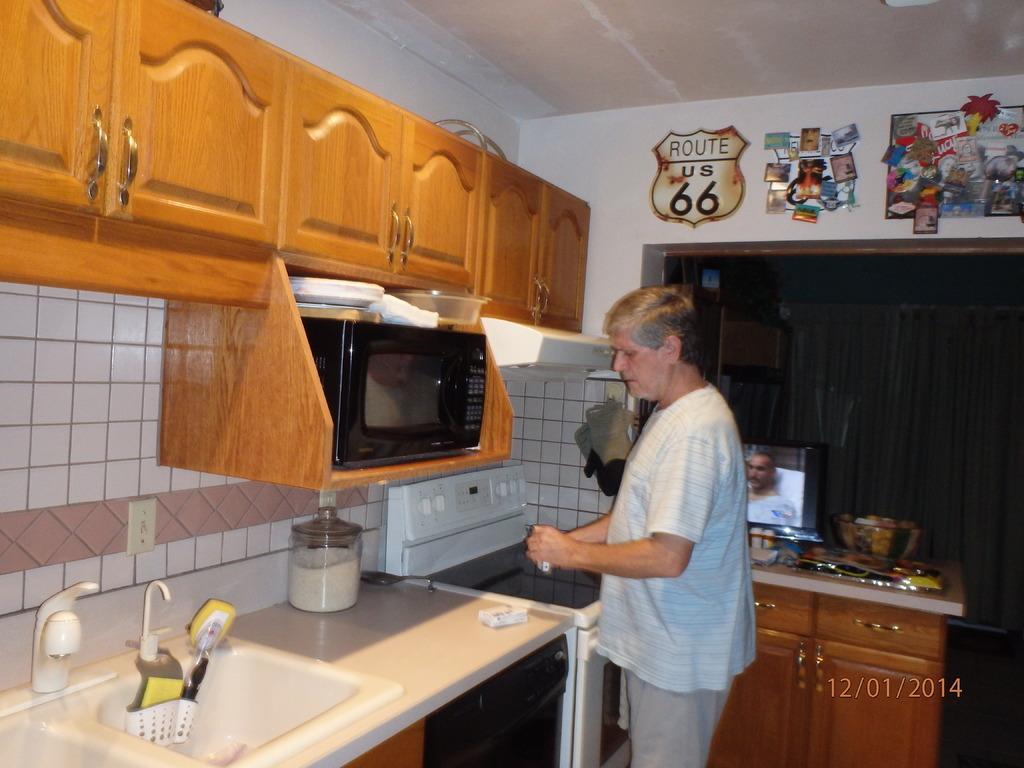Could you give a brief overview of what you see in this image? In this image I can see a kitchen, at the top there are cupboards and the wall there are some stickers attached to the wall, bottom of cupboard there is a micro oven visible ,at the bottom there is a kitchen cabinet,sink, glass jar, in front of kitchen cabinet there is a person and there is another table visible on the right side , on the table there is a screen and some objects visible 